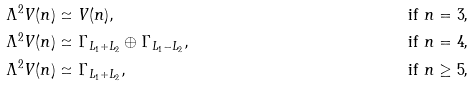<formula> <loc_0><loc_0><loc_500><loc_500>\Lambda ^ { 2 } V ( n ) & \simeq V ( n ) , & \text {if $n = 3$,} \\ \Lambda ^ { 2 } V ( n ) & \simeq \Gamma _ { L _ { 1 } + L _ { 2 } } \oplus \Gamma _ { L _ { 1 } - L _ { 2 } } , & \text {if $n = 4$,} \\ \Lambda ^ { 2 } V ( n ) & \simeq \Gamma _ { L _ { 1 } + L _ { 2 } } , & \text {if $n \geq 5$,}</formula> 